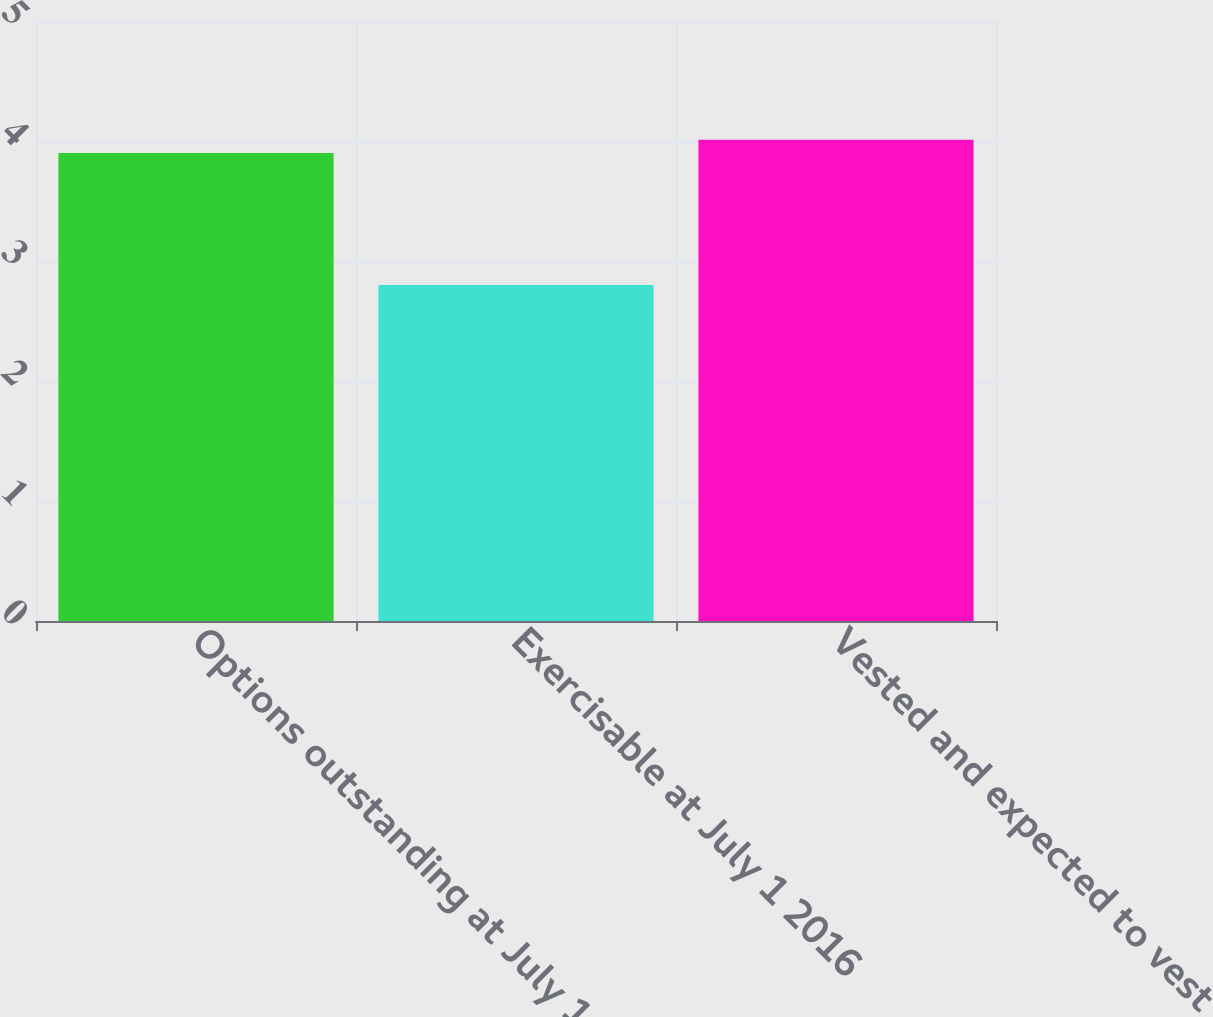Convert chart. <chart><loc_0><loc_0><loc_500><loc_500><bar_chart><fcel>Options outstanding at July 1<fcel>Exercisable at July 1 2016<fcel>Vested and expected to vest<nl><fcel>3.9<fcel>2.8<fcel>4.01<nl></chart> 